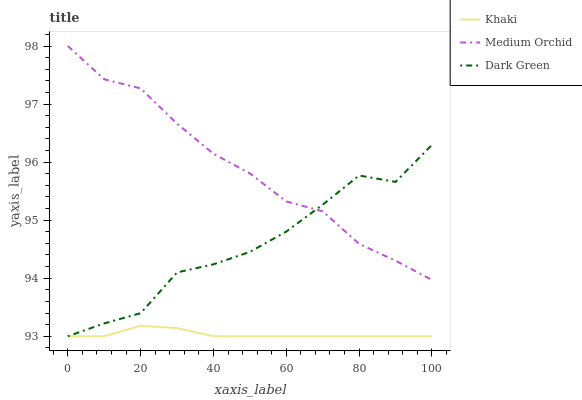Does Khaki have the minimum area under the curve?
Answer yes or no. Yes. Does Medium Orchid have the maximum area under the curve?
Answer yes or no. Yes. Does Dark Green have the minimum area under the curve?
Answer yes or no. No. Does Dark Green have the maximum area under the curve?
Answer yes or no. No. Is Khaki the smoothest?
Answer yes or no. Yes. Is Dark Green the roughest?
Answer yes or no. Yes. Is Dark Green the smoothest?
Answer yes or no. No. Is Khaki the roughest?
Answer yes or no. No. Does Khaki have the lowest value?
Answer yes or no. Yes. Does Medium Orchid have the highest value?
Answer yes or no. Yes. Does Dark Green have the highest value?
Answer yes or no. No. Is Khaki less than Medium Orchid?
Answer yes or no. Yes. Is Medium Orchid greater than Khaki?
Answer yes or no. Yes. Does Medium Orchid intersect Dark Green?
Answer yes or no. Yes. Is Medium Orchid less than Dark Green?
Answer yes or no. No. Is Medium Orchid greater than Dark Green?
Answer yes or no. No. Does Khaki intersect Medium Orchid?
Answer yes or no. No. 